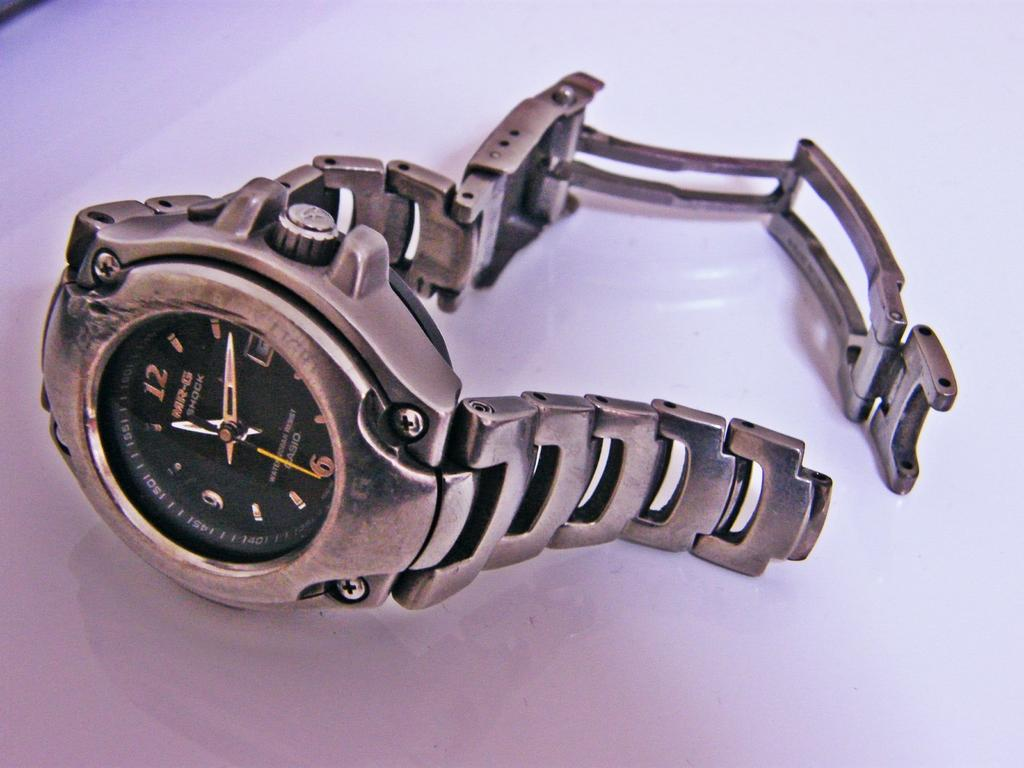<image>
Provide a brief description of the given image. Oasio silver and black MR-G shock watch for arms. 